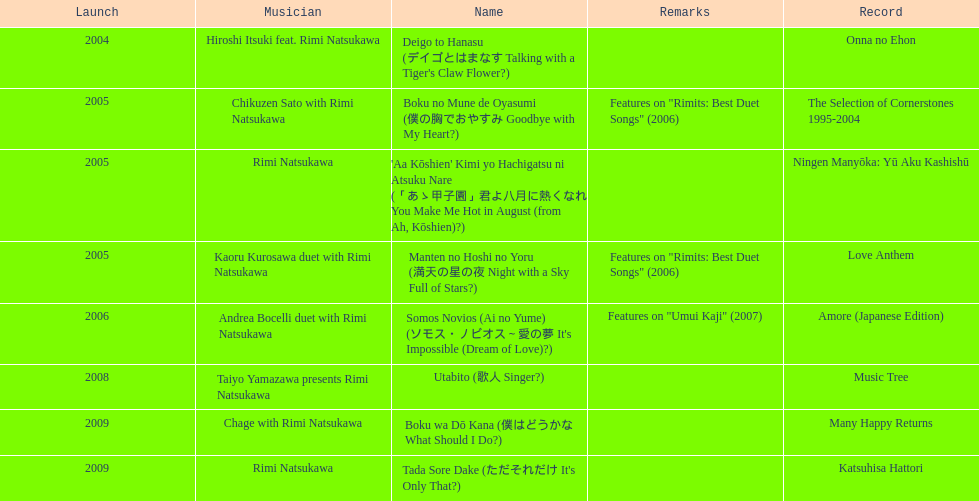What is the number of albums released with the artist rimi natsukawa? 8. 